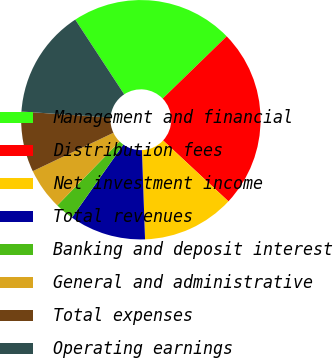Convert chart to OTSL. <chart><loc_0><loc_0><loc_500><loc_500><pie_chart><fcel>Management and financial<fcel>Distribution fees<fcel>Net investment income<fcel>Total revenues<fcel>Banking and deposit interest<fcel>General and administrative<fcel>Total expenses<fcel>Operating earnings<nl><fcel>21.96%<fcel>24.21%<fcel>12.5%<fcel>10.33%<fcel>2.53%<fcel>5.63%<fcel>8.16%<fcel>14.67%<nl></chart> 